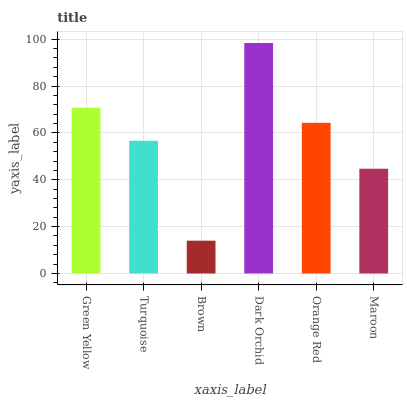Is Brown the minimum?
Answer yes or no. Yes. Is Dark Orchid the maximum?
Answer yes or no. Yes. Is Turquoise the minimum?
Answer yes or no. No. Is Turquoise the maximum?
Answer yes or no. No. Is Green Yellow greater than Turquoise?
Answer yes or no. Yes. Is Turquoise less than Green Yellow?
Answer yes or no. Yes. Is Turquoise greater than Green Yellow?
Answer yes or no. No. Is Green Yellow less than Turquoise?
Answer yes or no. No. Is Orange Red the high median?
Answer yes or no. Yes. Is Turquoise the low median?
Answer yes or no. Yes. Is Green Yellow the high median?
Answer yes or no. No. Is Green Yellow the low median?
Answer yes or no. No. 